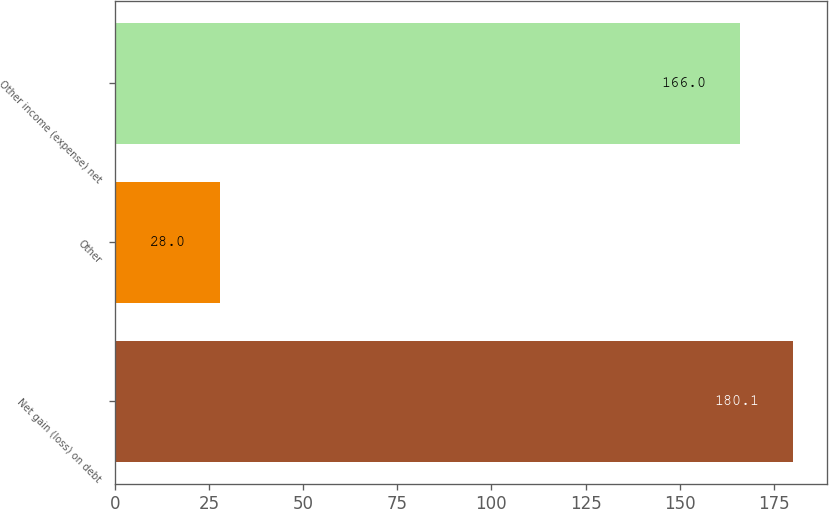<chart> <loc_0><loc_0><loc_500><loc_500><bar_chart><fcel>Net gain (loss) on debt<fcel>Other<fcel>Other income (expense) net<nl><fcel>180.1<fcel>28<fcel>166<nl></chart> 